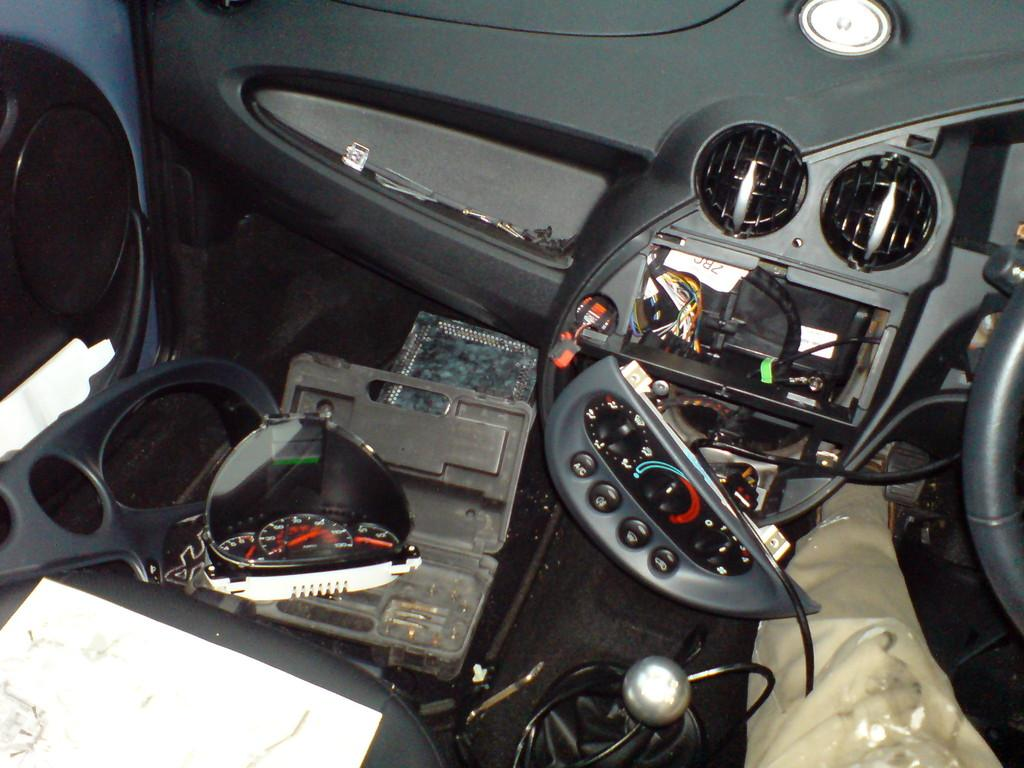Where was the image likely taken? The image appears to be taken inside a car. What can be seen in the image that is related to the car? There are parts of a car visible in the image. What else can be seen in the image besides car parts? There are wires, a box, and a paper present in the image. What type of gold or brass object is visible in the image? There is no gold or brass object present in the image. Who is the writer in the image? There is no writer present in the image. 